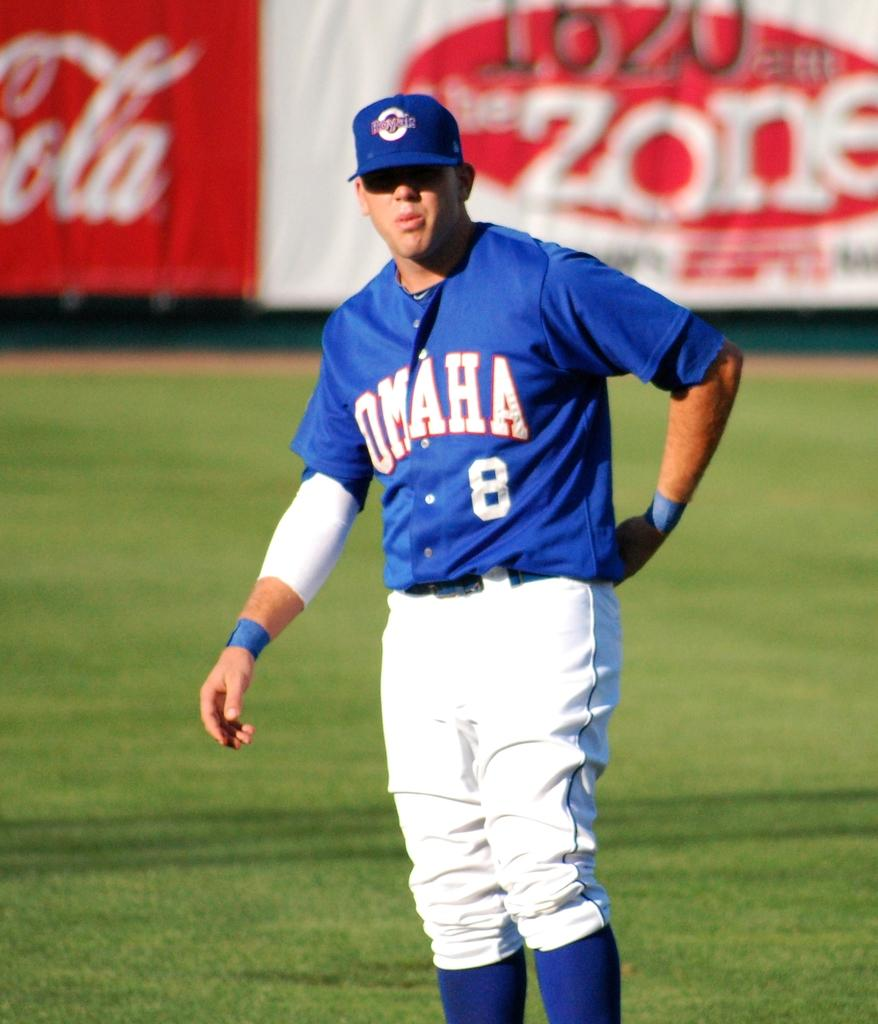<image>
Describe the image concisely. A baseball player has the team name Omaha on his jersey. 